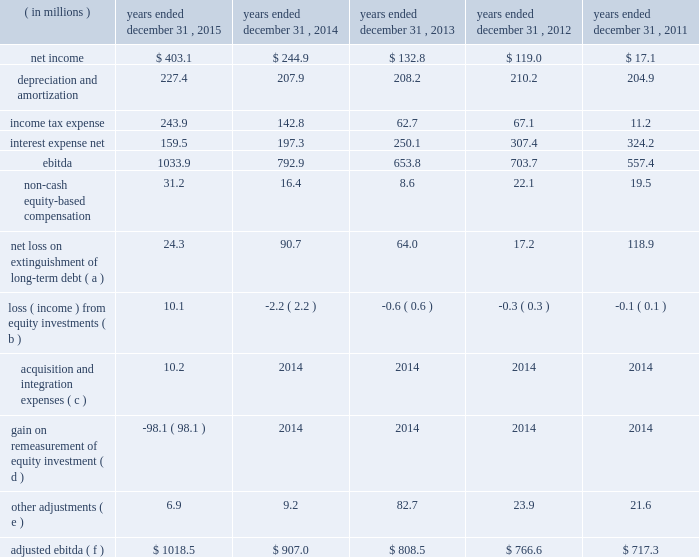Table of contents ( 2 ) includes capitalized lease obligations of $ 3.2 million and $ 0.1 million as of december 31 , 2015 and 2014 , respectively , which are included in other liabilities on the consolidated balance sheet .
( 3 ) ebitda is defined as consolidated net income before interest expense , income tax expense , depreciation and amortization .
Adjusted ebitda , which is a measure defined in our credit agreements , means ebitda adjusted for certain items which are described in the table below .
We have included a reconciliation of ebitda and adjusted ebitda in the table below .
Both ebitda and adjusted ebitda are considered non-gaap financial measures .
Generally , a non-gaap financial measure is a numerical measure of a company 2019s performance , financial position or cash flows that either excludes or includes amounts that are not normally included or excluded in the most directly comparable measure calculated and presented in accordance with gaap .
Non-gaap measures used by us may differ from similar measures used by other companies , even when similar terms are used to identify such measures .
We believe that ebitda and adjusted ebitda provide helpful information with respect to our operating performance and cash flows including our ability to meet our future debt service , capital expenditures and working capital requirements .
Adjusted ebitda is also the primary measure used in certain key covenants and definitions contained in the credit agreement governing our senior secured term loan facility ( 201cterm loan 201d ) , including the excess cash flow payment provision , the restricted payment covenant and the net leverage ratio .
These covenants and definitions are material components of the term loan as they are used in determining the interest rate applicable to the term loan , our ability to make certain investments , incur additional debt , and make restricted payments , such as dividends and share repurchases , as well as whether we are required to make additional principal prepayments on the term loan beyond the quarterly amortization payments .
For further details regarding the term loan , see note 8 ( long-term debt ) to the accompanying consolidated financial statements .
The following unaudited table sets forth reconciliations of net income to ebitda and ebitda to adjusted ebitda for the periods presented: .
Net loss on extinguishment of long-term debt ( a ) 24.3 90.7 64.0 17.2 118.9 loss ( income ) from equity investments ( b ) 10.1 ( 2.2 ) ( 0.6 ) ( 0.3 ) ( 0.1 ) acquisition and integration expenses ( c ) 10.2 2014 2014 2014 2014 gain on remeasurement of equity investment ( d ) ( 98.1 ) 2014 2014 2014 2014 other adjustments ( e ) 6.9 9.2 82.7 23.9 21.6 adjusted ebitda ( f ) $ 1018.5 $ 907.0 $ 808.5 $ 766.6 $ 717.3 ( a ) during the years ended december 31 , 2015 , 2014 , 2013 , 2012 , and 2011 , we recorded net losses on extinguishments of long-term debt .
The losses represented the difference between the amount paid upon extinguishment , including call premiums and expenses paid to the debt holders and agents , and the net carrying amount of the extinguished debt , adjusted for a portion of the unamortized deferred financing costs .
( b ) represents our share of net income/loss from our equity investments .
Our 35% ( 35 % ) share of kelway 2019s net loss includes our 35% ( 35 % ) share of an expense related to certain equity awards granted by one of the sellers to kelway coworkers in july 2015 prior to the acquisition .
( c ) primarily includes expenses related to the acquisition of kelway .
( d ) represents the gain resulting from the remeasurement of our previously held 35% ( 35 % ) equity investment to fair value upon the completion of the acquisition of kelway. .
What was the 2015 rate of increase in adjusted ebitda? 
Computations: ((1018.5 - 907.0) / 907.0)
Answer: 0.12293. 